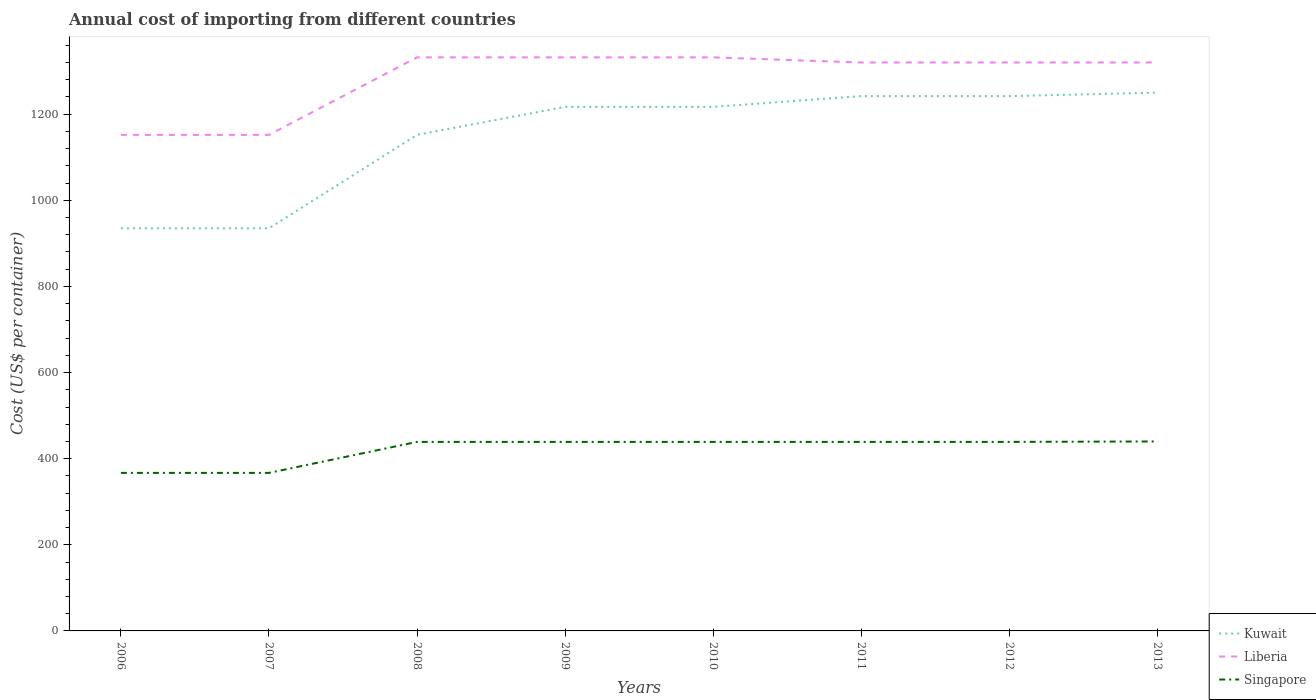Is the number of lines equal to the number of legend labels?
Provide a succinct answer. Yes. Across all years, what is the maximum total annual cost of importing in Liberia?
Ensure brevity in your answer.  1152. In which year was the total annual cost of importing in Singapore maximum?
Keep it short and to the point. 2006. What is the total total annual cost of importing in Kuwait in the graph?
Your answer should be very brief. -65. What is the difference between the highest and the second highest total annual cost of importing in Kuwait?
Give a very brief answer. 315. Is the total annual cost of importing in Singapore strictly greater than the total annual cost of importing in Kuwait over the years?
Give a very brief answer. Yes. Does the graph contain grids?
Provide a succinct answer. No. Where does the legend appear in the graph?
Provide a short and direct response. Bottom right. How many legend labels are there?
Offer a terse response. 3. What is the title of the graph?
Provide a succinct answer. Annual cost of importing from different countries. What is the label or title of the X-axis?
Your response must be concise. Years. What is the label or title of the Y-axis?
Your answer should be very brief. Cost (US$ per container). What is the Cost (US$ per container) of Kuwait in 2006?
Make the answer very short. 935. What is the Cost (US$ per container) of Liberia in 2006?
Ensure brevity in your answer.  1152. What is the Cost (US$ per container) of Singapore in 2006?
Give a very brief answer. 367. What is the Cost (US$ per container) of Kuwait in 2007?
Your answer should be compact. 935. What is the Cost (US$ per container) in Liberia in 2007?
Keep it short and to the point. 1152. What is the Cost (US$ per container) in Singapore in 2007?
Your answer should be compact. 367. What is the Cost (US$ per container) of Kuwait in 2008?
Make the answer very short. 1152. What is the Cost (US$ per container) in Liberia in 2008?
Offer a very short reply. 1332. What is the Cost (US$ per container) of Singapore in 2008?
Offer a terse response. 439. What is the Cost (US$ per container) in Kuwait in 2009?
Provide a short and direct response. 1217. What is the Cost (US$ per container) of Liberia in 2009?
Keep it short and to the point. 1332. What is the Cost (US$ per container) in Singapore in 2009?
Offer a terse response. 439. What is the Cost (US$ per container) in Kuwait in 2010?
Your answer should be compact. 1217. What is the Cost (US$ per container) of Liberia in 2010?
Keep it short and to the point. 1332. What is the Cost (US$ per container) in Singapore in 2010?
Your answer should be very brief. 439. What is the Cost (US$ per container) of Kuwait in 2011?
Your response must be concise. 1242. What is the Cost (US$ per container) in Liberia in 2011?
Ensure brevity in your answer.  1320. What is the Cost (US$ per container) of Singapore in 2011?
Provide a short and direct response. 439. What is the Cost (US$ per container) in Kuwait in 2012?
Give a very brief answer. 1242. What is the Cost (US$ per container) of Liberia in 2012?
Provide a succinct answer. 1320. What is the Cost (US$ per container) of Singapore in 2012?
Ensure brevity in your answer.  439. What is the Cost (US$ per container) in Kuwait in 2013?
Ensure brevity in your answer.  1250. What is the Cost (US$ per container) of Liberia in 2013?
Your response must be concise. 1320. What is the Cost (US$ per container) of Singapore in 2013?
Make the answer very short. 440. Across all years, what is the maximum Cost (US$ per container) of Kuwait?
Offer a very short reply. 1250. Across all years, what is the maximum Cost (US$ per container) in Liberia?
Your answer should be compact. 1332. Across all years, what is the maximum Cost (US$ per container) in Singapore?
Offer a terse response. 440. Across all years, what is the minimum Cost (US$ per container) in Kuwait?
Your answer should be compact. 935. Across all years, what is the minimum Cost (US$ per container) in Liberia?
Ensure brevity in your answer.  1152. Across all years, what is the minimum Cost (US$ per container) in Singapore?
Provide a short and direct response. 367. What is the total Cost (US$ per container) in Kuwait in the graph?
Your answer should be compact. 9190. What is the total Cost (US$ per container) of Liberia in the graph?
Offer a terse response. 1.03e+04. What is the total Cost (US$ per container) of Singapore in the graph?
Provide a succinct answer. 3369. What is the difference between the Cost (US$ per container) of Liberia in 2006 and that in 2007?
Offer a very short reply. 0. What is the difference between the Cost (US$ per container) in Singapore in 2006 and that in 2007?
Ensure brevity in your answer.  0. What is the difference between the Cost (US$ per container) in Kuwait in 2006 and that in 2008?
Your answer should be very brief. -217. What is the difference between the Cost (US$ per container) of Liberia in 2006 and that in 2008?
Provide a short and direct response. -180. What is the difference between the Cost (US$ per container) of Singapore in 2006 and that in 2008?
Offer a terse response. -72. What is the difference between the Cost (US$ per container) of Kuwait in 2006 and that in 2009?
Give a very brief answer. -282. What is the difference between the Cost (US$ per container) in Liberia in 2006 and that in 2009?
Your answer should be compact. -180. What is the difference between the Cost (US$ per container) in Singapore in 2006 and that in 2009?
Give a very brief answer. -72. What is the difference between the Cost (US$ per container) of Kuwait in 2006 and that in 2010?
Your response must be concise. -282. What is the difference between the Cost (US$ per container) of Liberia in 2006 and that in 2010?
Keep it short and to the point. -180. What is the difference between the Cost (US$ per container) of Singapore in 2006 and that in 2010?
Your response must be concise. -72. What is the difference between the Cost (US$ per container) in Kuwait in 2006 and that in 2011?
Provide a short and direct response. -307. What is the difference between the Cost (US$ per container) of Liberia in 2006 and that in 2011?
Offer a terse response. -168. What is the difference between the Cost (US$ per container) in Singapore in 2006 and that in 2011?
Offer a terse response. -72. What is the difference between the Cost (US$ per container) in Kuwait in 2006 and that in 2012?
Your response must be concise. -307. What is the difference between the Cost (US$ per container) of Liberia in 2006 and that in 2012?
Make the answer very short. -168. What is the difference between the Cost (US$ per container) of Singapore in 2006 and that in 2012?
Keep it short and to the point. -72. What is the difference between the Cost (US$ per container) of Kuwait in 2006 and that in 2013?
Offer a very short reply. -315. What is the difference between the Cost (US$ per container) of Liberia in 2006 and that in 2013?
Your response must be concise. -168. What is the difference between the Cost (US$ per container) of Singapore in 2006 and that in 2013?
Ensure brevity in your answer.  -73. What is the difference between the Cost (US$ per container) in Kuwait in 2007 and that in 2008?
Make the answer very short. -217. What is the difference between the Cost (US$ per container) of Liberia in 2007 and that in 2008?
Give a very brief answer. -180. What is the difference between the Cost (US$ per container) in Singapore in 2007 and that in 2008?
Offer a very short reply. -72. What is the difference between the Cost (US$ per container) of Kuwait in 2007 and that in 2009?
Keep it short and to the point. -282. What is the difference between the Cost (US$ per container) in Liberia in 2007 and that in 2009?
Your answer should be compact. -180. What is the difference between the Cost (US$ per container) of Singapore in 2007 and that in 2009?
Give a very brief answer. -72. What is the difference between the Cost (US$ per container) of Kuwait in 2007 and that in 2010?
Give a very brief answer. -282. What is the difference between the Cost (US$ per container) in Liberia in 2007 and that in 2010?
Your answer should be compact. -180. What is the difference between the Cost (US$ per container) of Singapore in 2007 and that in 2010?
Make the answer very short. -72. What is the difference between the Cost (US$ per container) of Kuwait in 2007 and that in 2011?
Your answer should be very brief. -307. What is the difference between the Cost (US$ per container) in Liberia in 2007 and that in 2011?
Your answer should be compact. -168. What is the difference between the Cost (US$ per container) of Singapore in 2007 and that in 2011?
Ensure brevity in your answer.  -72. What is the difference between the Cost (US$ per container) in Kuwait in 2007 and that in 2012?
Keep it short and to the point. -307. What is the difference between the Cost (US$ per container) in Liberia in 2007 and that in 2012?
Offer a very short reply. -168. What is the difference between the Cost (US$ per container) of Singapore in 2007 and that in 2012?
Your response must be concise. -72. What is the difference between the Cost (US$ per container) in Kuwait in 2007 and that in 2013?
Your response must be concise. -315. What is the difference between the Cost (US$ per container) of Liberia in 2007 and that in 2013?
Offer a very short reply. -168. What is the difference between the Cost (US$ per container) of Singapore in 2007 and that in 2013?
Offer a terse response. -73. What is the difference between the Cost (US$ per container) of Kuwait in 2008 and that in 2009?
Offer a very short reply. -65. What is the difference between the Cost (US$ per container) of Singapore in 2008 and that in 2009?
Offer a terse response. 0. What is the difference between the Cost (US$ per container) of Kuwait in 2008 and that in 2010?
Your response must be concise. -65. What is the difference between the Cost (US$ per container) in Kuwait in 2008 and that in 2011?
Keep it short and to the point. -90. What is the difference between the Cost (US$ per container) in Liberia in 2008 and that in 2011?
Provide a short and direct response. 12. What is the difference between the Cost (US$ per container) in Kuwait in 2008 and that in 2012?
Offer a very short reply. -90. What is the difference between the Cost (US$ per container) in Liberia in 2008 and that in 2012?
Provide a short and direct response. 12. What is the difference between the Cost (US$ per container) of Kuwait in 2008 and that in 2013?
Provide a short and direct response. -98. What is the difference between the Cost (US$ per container) of Singapore in 2008 and that in 2013?
Your response must be concise. -1. What is the difference between the Cost (US$ per container) in Liberia in 2009 and that in 2010?
Offer a terse response. 0. What is the difference between the Cost (US$ per container) in Liberia in 2009 and that in 2011?
Give a very brief answer. 12. What is the difference between the Cost (US$ per container) in Singapore in 2009 and that in 2011?
Your answer should be very brief. 0. What is the difference between the Cost (US$ per container) in Kuwait in 2009 and that in 2013?
Keep it short and to the point. -33. What is the difference between the Cost (US$ per container) in Liberia in 2010 and that in 2011?
Your answer should be compact. 12. What is the difference between the Cost (US$ per container) in Singapore in 2010 and that in 2011?
Make the answer very short. 0. What is the difference between the Cost (US$ per container) in Singapore in 2010 and that in 2012?
Offer a very short reply. 0. What is the difference between the Cost (US$ per container) in Kuwait in 2010 and that in 2013?
Provide a succinct answer. -33. What is the difference between the Cost (US$ per container) in Liberia in 2010 and that in 2013?
Your answer should be very brief. 12. What is the difference between the Cost (US$ per container) of Singapore in 2010 and that in 2013?
Provide a succinct answer. -1. What is the difference between the Cost (US$ per container) in Liberia in 2011 and that in 2012?
Your answer should be very brief. 0. What is the difference between the Cost (US$ per container) of Kuwait in 2011 and that in 2013?
Provide a short and direct response. -8. What is the difference between the Cost (US$ per container) in Liberia in 2011 and that in 2013?
Ensure brevity in your answer.  0. What is the difference between the Cost (US$ per container) of Liberia in 2012 and that in 2013?
Offer a terse response. 0. What is the difference between the Cost (US$ per container) in Singapore in 2012 and that in 2013?
Your response must be concise. -1. What is the difference between the Cost (US$ per container) in Kuwait in 2006 and the Cost (US$ per container) in Liberia in 2007?
Give a very brief answer. -217. What is the difference between the Cost (US$ per container) of Kuwait in 2006 and the Cost (US$ per container) of Singapore in 2007?
Your answer should be compact. 568. What is the difference between the Cost (US$ per container) in Liberia in 2006 and the Cost (US$ per container) in Singapore in 2007?
Your answer should be very brief. 785. What is the difference between the Cost (US$ per container) of Kuwait in 2006 and the Cost (US$ per container) of Liberia in 2008?
Make the answer very short. -397. What is the difference between the Cost (US$ per container) in Kuwait in 2006 and the Cost (US$ per container) in Singapore in 2008?
Offer a very short reply. 496. What is the difference between the Cost (US$ per container) in Liberia in 2006 and the Cost (US$ per container) in Singapore in 2008?
Your response must be concise. 713. What is the difference between the Cost (US$ per container) of Kuwait in 2006 and the Cost (US$ per container) of Liberia in 2009?
Provide a succinct answer. -397. What is the difference between the Cost (US$ per container) in Kuwait in 2006 and the Cost (US$ per container) in Singapore in 2009?
Your answer should be compact. 496. What is the difference between the Cost (US$ per container) of Liberia in 2006 and the Cost (US$ per container) of Singapore in 2009?
Your response must be concise. 713. What is the difference between the Cost (US$ per container) in Kuwait in 2006 and the Cost (US$ per container) in Liberia in 2010?
Offer a terse response. -397. What is the difference between the Cost (US$ per container) in Kuwait in 2006 and the Cost (US$ per container) in Singapore in 2010?
Keep it short and to the point. 496. What is the difference between the Cost (US$ per container) of Liberia in 2006 and the Cost (US$ per container) of Singapore in 2010?
Offer a terse response. 713. What is the difference between the Cost (US$ per container) of Kuwait in 2006 and the Cost (US$ per container) of Liberia in 2011?
Your answer should be very brief. -385. What is the difference between the Cost (US$ per container) of Kuwait in 2006 and the Cost (US$ per container) of Singapore in 2011?
Keep it short and to the point. 496. What is the difference between the Cost (US$ per container) of Liberia in 2006 and the Cost (US$ per container) of Singapore in 2011?
Your answer should be compact. 713. What is the difference between the Cost (US$ per container) of Kuwait in 2006 and the Cost (US$ per container) of Liberia in 2012?
Offer a very short reply. -385. What is the difference between the Cost (US$ per container) in Kuwait in 2006 and the Cost (US$ per container) in Singapore in 2012?
Give a very brief answer. 496. What is the difference between the Cost (US$ per container) of Liberia in 2006 and the Cost (US$ per container) of Singapore in 2012?
Make the answer very short. 713. What is the difference between the Cost (US$ per container) of Kuwait in 2006 and the Cost (US$ per container) of Liberia in 2013?
Your answer should be very brief. -385. What is the difference between the Cost (US$ per container) in Kuwait in 2006 and the Cost (US$ per container) in Singapore in 2013?
Offer a terse response. 495. What is the difference between the Cost (US$ per container) in Liberia in 2006 and the Cost (US$ per container) in Singapore in 2013?
Keep it short and to the point. 712. What is the difference between the Cost (US$ per container) in Kuwait in 2007 and the Cost (US$ per container) in Liberia in 2008?
Ensure brevity in your answer.  -397. What is the difference between the Cost (US$ per container) of Kuwait in 2007 and the Cost (US$ per container) of Singapore in 2008?
Your answer should be very brief. 496. What is the difference between the Cost (US$ per container) of Liberia in 2007 and the Cost (US$ per container) of Singapore in 2008?
Give a very brief answer. 713. What is the difference between the Cost (US$ per container) of Kuwait in 2007 and the Cost (US$ per container) of Liberia in 2009?
Provide a short and direct response. -397. What is the difference between the Cost (US$ per container) of Kuwait in 2007 and the Cost (US$ per container) of Singapore in 2009?
Provide a succinct answer. 496. What is the difference between the Cost (US$ per container) in Liberia in 2007 and the Cost (US$ per container) in Singapore in 2009?
Provide a short and direct response. 713. What is the difference between the Cost (US$ per container) in Kuwait in 2007 and the Cost (US$ per container) in Liberia in 2010?
Your response must be concise. -397. What is the difference between the Cost (US$ per container) in Kuwait in 2007 and the Cost (US$ per container) in Singapore in 2010?
Your response must be concise. 496. What is the difference between the Cost (US$ per container) in Liberia in 2007 and the Cost (US$ per container) in Singapore in 2010?
Your answer should be very brief. 713. What is the difference between the Cost (US$ per container) of Kuwait in 2007 and the Cost (US$ per container) of Liberia in 2011?
Give a very brief answer. -385. What is the difference between the Cost (US$ per container) of Kuwait in 2007 and the Cost (US$ per container) of Singapore in 2011?
Your response must be concise. 496. What is the difference between the Cost (US$ per container) in Liberia in 2007 and the Cost (US$ per container) in Singapore in 2011?
Your response must be concise. 713. What is the difference between the Cost (US$ per container) in Kuwait in 2007 and the Cost (US$ per container) in Liberia in 2012?
Offer a terse response. -385. What is the difference between the Cost (US$ per container) of Kuwait in 2007 and the Cost (US$ per container) of Singapore in 2012?
Ensure brevity in your answer.  496. What is the difference between the Cost (US$ per container) of Liberia in 2007 and the Cost (US$ per container) of Singapore in 2012?
Offer a terse response. 713. What is the difference between the Cost (US$ per container) in Kuwait in 2007 and the Cost (US$ per container) in Liberia in 2013?
Keep it short and to the point. -385. What is the difference between the Cost (US$ per container) in Kuwait in 2007 and the Cost (US$ per container) in Singapore in 2013?
Provide a succinct answer. 495. What is the difference between the Cost (US$ per container) of Liberia in 2007 and the Cost (US$ per container) of Singapore in 2013?
Offer a terse response. 712. What is the difference between the Cost (US$ per container) of Kuwait in 2008 and the Cost (US$ per container) of Liberia in 2009?
Offer a terse response. -180. What is the difference between the Cost (US$ per container) of Kuwait in 2008 and the Cost (US$ per container) of Singapore in 2009?
Provide a succinct answer. 713. What is the difference between the Cost (US$ per container) of Liberia in 2008 and the Cost (US$ per container) of Singapore in 2009?
Provide a short and direct response. 893. What is the difference between the Cost (US$ per container) in Kuwait in 2008 and the Cost (US$ per container) in Liberia in 2010?
Provide a short and direct response. -180. What is the difference between the Cost (US$ per container) of Kuwait in 2008 and the Cost (US$ per container) of Singapore in 2010?
Make the answer very short. 713. What is the difference between the Cost (US$ per container) of Liberia in 2008 and the Cost (US$ per container) of Singapore in 2010?
Your response must be concise. 893. What is the difference between the Cost (US$ per container) in Kuwait in 2008 and the Cost (US$ per container) in Liberia in 2011?
Offer a terse response. -168. What is the difference between the Cost (US$ per container) in Kuwait in 2008 and the Cost (US$ per container) in Singapore in 2011?
Your answer should be compact. 713. What is the difference between the Cost (US$ per container) of Liberia in 2008 and the Cost (US$ per container) of Singapore in 2011?
Provide a short and direct response. 893. What is the difference between the Cost (US$ per container) in Kuwait in 2008 and the Cost (US$ per container) in Liberia in 2012?
Offer a very short reply. -168. What is the difference between the Cost (US$ per container) in Kuwait in 2008 and the Cost (US$ per container) in Singapore in 2012?
Offer a terse response. 713. What is the difference between the Cost (US$ per container) in Liberia in 2008 and the Cost (US$ per container) in Singapore in 2012?
Your response must be concise. 893. What is the difference between the Cost (US$ per container) of Kuwait in 2008 and the Cost (US$ per container) of Liberia in 2013?
Ensure brevity in your answer.  -168. What is the difference between the Cost (US$ per container) in Kuwait in 2008 and the Cost (US$ per container) in Singapore in 2013?
Offer a very short reply. 712. What is the difference between the Cost (US$ per container) of Liberia in 2008 and the Cost (US$ per container) of Singapore in 2013?
Offer a terse response. 892. What is the difference between the Cost (US$ per container) of Kuwait in 2009 and the Cost (US$ per container) of Liberia in 2010?
Offer a terse response. -115. What is the difference between the Cost (US$ per container) of Kuwait in 2009 and the Cost (US$ per container) of Singapore in 2010?
Offer a terse response. 778. What is the difference between the Cost (US$ per container) in Liberia in 2009 and the Cost (US$ per container) in Singapore in 2010?
Provide a succinct answer. 893. What is the difference between the Cost (US$ per container) of Kuwait in 2009 and the Cost (US$ per container) of Liberia in 2011?
Provide a short and direct response. -103. What is the difference between the Cost (US$ per container) of Kuwait in 2009 and the Cost (US$ per container) of Singapore in 2011?
Your answer should be very brief. 778. What is the difference between the Cost (US$ per container) in Liberia in 2009 and the Cost (US$ per container) in Singapore in 2011?
Your response must be concise. 893. What is the difference between the Cost (US$ per container) in Kuwait in 2009 and the Cost (US$ per container) in Liberia in 2012?
Provide a succinct answer. -103. What is the difference between the Cost (US$ per container) in Kuwait in 2009 and the Cost (US$ per container) in Singapore in 2012?
Provide a short and direct response. 778. What is the difference between the Cost (US$ per container) in Liberia in 2009 and the Cost (US$ per container) in Singapore in 2012?
Offer a terse response. 893. What is the difference between the Cost (US$ per container) of Kuwait in 2009 and the Cost (US$ per container) of Liberia in 2013?
Your answer should be very brief. -103. What is the difference between the Cost (US$ per container) of Kuwait in 2009 and the Cost (US$ per container) of Singapore in 2013?
Provide a short and direct response. 777. What is the difference between the Cost (US$ per container) of Liberia in 2009 and the Cost (US$ per container) of Singapore in 2013?
Ensure brevity in your answer.  892. What is the difference between the Cost (US$ per container) of Kuwait in 2010 and the Cost (US$ per container) of Liberia in 2011?
Ensure brevity in your answer.  -103. What is the difference between the Cost (US$ per container) of Kuwait in 2010 and the Cost (US$ per container) of Singapore in 2011?
Keep it short and to the point. 778. What is the difference between the Cost (US$ per container) in Liberia in 2010 and the Cost (US$ per container) in Singapore in 2011?
Your answer should be very brief. 893. What is the difference between the Cost (US$ per container) in Kuwait in 2010 and the Cost (US$ per container) in Liberia in 2012?
Provide a short and direct response. -103. What is the difference between the Cost (US$ per container) of Kuwait in 2010 and the Cost (US$ per container) of Singapore in 2012?
Offer a terse response. 778. What is the difference between the Cost (US$ per container) in Liberia in 2010 and the Cost (US$ per container) in Singapore in 2012?
Provide a succinct answer. 893. What is the difference between the Cost (US$ per container) of Kuwait in 2010 and the Cost (US$ per container) of Liberia in 2013?
Keep it short and to the point. -103. What is the difference between the Cost (US$ per container) in Kuwait in 2010 and the Cost (US$ per container) in Singapore in 2013?
Offer a very short reply. 777. What is the difference between the Cost (US$ per container) of Liberia in 2010 and the Cost (US$ per container) of Singapore in 2013?
Keep it short and to the point. 892. What is the difference between the Cost (US$ per container) of Kuwait in 2011 and the Cost (US$ per container) of Liberia in 2012?
Your response must be concise. -78. What is the difference between the Cost (US$ per container) of Kuwait in 2011 and the Cost (US$ per container) of Singapore in 2012?
Your answer should be very brief. 803. What is the difference between the Cost (US$ per container) in Liberia in 2011 and the Cost (US$ per container) in Singapore in 2012?
Offer a very short reply. 881. What is the difference between the Cost (US$ per container) of Kuwait in 2011 and the Cost (US$ per container) of Liberia in 2013?
Make the answer very short. -78. What is the difference between the Cost (US$ per container) of Kuwait in 2011 and the Cost (US$ per container) of Singapore in 2013?
Make the answer very short. 802. What is the difference between the Cost (US$ per container) of Liberia in 2011 and the Cost (US$ per container) of Singapore in 2013?
Keep it short and to the point. 880. What is the difference between the Cost (US$ per container) of Kuwait in 2012 and the Cost (US$ per container) of Liberia in 2013?
Ensure brevity in your answer.  -78. What is the difference between the Cost (US$ per container) of Kuwait in 2012 and the Cost (US$ per container) of Singapore in 2013?
Provide a succinct answer. 802. What is the difference between the Cost (US$ per container) of Liberia in 2012 and the Cost (US$ per container) of Singapore in 2013?
Keep it short and to the point. 880. What is the average Cost (US$ per container) of Kuwait per year?
Keep it short and to the point. 1148.75. What is the average Cost (US$ per container) in Liberia per year?
Offer a very short reply. 1282.5. What is the average Cost (US$ per container) of Singapore per year?
Provide a short and direct response. 421.12. In the year 2006, what is the difference between the Cost (US$ per container) of Kuwait and Cost (US$ per container) of Liberia?
Offer a terse response. -217. In the year 2006, what is the difference between the Cost (US$ per container) of Kuwait and Cost (US$ per container) of Singapore?
Offer a terse response. 568. In the year 2006, what is the difference between the Cost (US$ per container) in Liberia and Cost (US$ per container) in Singapore?
Provide a short and direct response. 785. In the year 2007, what is the difference between the Cost (US$ per container) of Kuwait and Cost (US$ per container) of Liberia?
Offer a terse response. -217. In the year 2007, what is the difference between the Cost (US$ per container) of Kuwait and Cost (US$ per container) of Singapore?
Provide a short and direct response. 568. In the year 2007, what is the difference between the Cost (US$ per container) of Liberia and Cost (US$ per container) of Singapore?
Offer a terse response. 785. In the year 2008, what is the difference between the Cost (US$ per container) of Kuwait and Cost (US$ per container) of Liberia?
Keep it short and to the point. -180. In the year 2008, what is the difference between the Cost (US$ per container) of Kuwait and Cost (US$ per container) of Singapore?
Ensure brevity in your answer.  713. In the year 2008, what is the difference between the Cost (US$ per container) of Liberia and Cost (US$ per container) of Singapore?
Make the answer very short. 893. In the year 2009, what is the difference between the Cost (US$ per container) in Kuwait and Cost (US$ per container) in Liberia?
Offer a very short reply. -115. In the year 2009, what is the difference between the Cost (US$ per container) of Kuwait and Cost (US$ per container) of Singapore?
Offer a terse response. 778. In the year 2009, what is the difference between the Cost (US$ per container) of Liberia and Cost (US$ per container) of Singapore?
Offer a terse response. 893. In the year 2010, what is the difference between the Cost (US$ per container) in Kuwait and Cost (US$ per container) in Liberia?
Offer a very short reply. -115. In the year 2010, what is the difference between the Cost (US$ per container) of Kuwait and Cost (US$ per container) of Singapore?
Provide a short and direct response. 778. In the year 2010, what is the difference between the Cost (US$ per container) in Liberia and Cost (US$ per container) in Singapore?
Ensure brevity in your answer.  893. In the year 2011, what is the difference between the Cost (US$ per container) in Kuwait and Cost (US$ per container) in Liberia?
Your answer should be very brief. -78. In the year 2011, what is the difference between the Cost (US$ per container) of Kuwait and Cost (US$ per container) of Singapore?
Provide a short and direct response. 803. In the year 2011, what is the difference between the Cost (US$ per container) of Liberia and Cost (US$ per container) of Singapore?
Make the answer very short. 881. In the year 2012, what is the difference between the Cost (US$ per container) of Kuwait and Cost (US$ per container) of Liberia?
Your response must be concise. -78. In the year 2012, what is the difference between the Cost (US$ per container) in Kuwait and Cost (US$ per container) in Singapore?
Offer a very short reply. 803. In the year 2012, what is the difference between the Cost (US$ per container) of Liberia and Cost (US$ per container) of Singapore?
Your response must be concise. 881. In the year 2013, what is the difference between the Cost (US$ per container) in Kuwait and Cost (US$ per container) in Liberia?
Offer a very short reply. -70. In the year 2013, what is the difference between the Cost (US$ per container) of Kuwait and Cost (US$ per container) of Singapore?
Your answer should be compact. 810. In the year 2013, what is the difference between the Cost (US$ per container) in Liberia and Cost (US$ per container) in Singapore?
Make the answer very short. 880. What is the ratio of the Cost (US$ per container) of Kuwait in 2006 to that in 2007?
Give a very brief answer. 1. What is the ratio of the Cost (US$ per container) of Kuwait in 2006 to that in 2008?
Make the answer very short. 0.81. What is the ratio of the Cost (US$ per container) in Liberia in 2006 to that in 2008?
Your response must be concise. 0.86. What is the ratio of the Cost (US$ per container) in Singapore in 2006 to that in 2008?
Give a very brief answer. 0.84. What is the ratio of the Cost (US$ per container) in Kuwait in 2006 to that in 2009?
Provide a succinct answer. 0.77. What is the ratio of the Cost (US$ per container) of Liberia in 2006 to that in 2009?
Your answer should be very brief. 0.86. What is the ratio of the Cost (US$ per container) in Singapore in 2006 to that in 2009?
Give a very brief answer. 0.84. What is the ratio of the Cost (US$ per container) of Kuwait in 2006 to that in 2010?
Make the answer very short. 0.77. What is the ratio of the Cost (US$ per container) of Liberia in 2006 to that in 2010?
Provide a succinct answer. 0.86. What is the ratio of the Cost (US$ per container) in Singapore in 2006 to that in 2010?
Give a very brief answer. 0.84. What is the ratio of the Cost (US$ per container) of Kuwait in 2006 to that in 2011?
Keep it short and to the point. 0.75. What is the ratio of the Cost (US$ per container) in Liberia in 2006 to that in 2011?
Offer a very short reply. 0.87. What is the ratio of the Cost (US$ per container) of Singapore in 2006 to that in 2011?
Give a very brief answer. 0.84. What is the ratio of the Cost (US$ per container) of Kuwait in 2006 to that in 2012?
Give a very brief answer. 0.75. What is the ratio of the Cost (US$ per container) of Liberia in 2006 to that in 2012?
Your answer should be very brief. 0.87. What is the ratio of the Cost (US$ per container) of Singapore in 2006 to that in 2012?
Provide a succinct answer. 0.84. What is the ratio of the Cost (US$ per container) of Kuwait in 2006 to that in 2013?
Your answer should be very brief. 0.75. What is the ratio of the Cost (US$ per container) of Liberia in 2006 to that in 2013?
Offer a very short reply. 0.87. What is the ratio of the Cost (US$ per container) of Singapore in 2006 to that in 2013?
Keep it short and to the point. 0.83. What is the ratio of the Cost (US$ per container) of Kuwait in 2007 to that in 2008?
Offer a very short reply. 0.81. What is the ratio of the Cost (US$ per container) of Liberia in 2007 to that in 2008?
Your answer should be very brief. 0.86. What is the ratio of the Cost (US$ per container) in Singapore in 2007 to that in 2008?
Ensure brevity in your answer.  0.84. What is the ratio of the Cost (US$ per container) in Kuwait in 2007 to that in 2009?
Your answer should be compact. 0.77. What is the ratio of the Cost (US$ per container) in Liberia in 2007 to that in 2009?
Provide a short and direct response. 0.86. What is the ratio of the Cost (US$ per container) of Singapore in 2007 to that in 2009?
Offer a terse response. 0.84. What is the ratio of the Cost (US$ per container) in Kuwait in 2007 to that in 2010?
Provide a succinct answer. 0.77. What is the ratio of the Cost (US$ per container) of Liberia in 2007 to that in 2010?
Your answer should be very brief. 0.86. What is the ratio of the Cost (US$ per container) in Singapore in 2007 to that in 2010?
Your answer should be compact. 0.84. What is the ratio of the Cost (US$ per container) of Kuwait in 2007 to that in 2011?
Your answer should be very brief. 0.75. What is the ratio of the Cost (US$ per container) of Liberia in 2007 to that in 2011?
Make the answer very short. 0.87. What is the ratio of the Cost (US$ per container) of Singapore in 2007 to that in 2011?
Make the answer very short. 0.84. What is the ratio of the Cost (US$ per container) in Kuwait in 2007 to that in 2012?
Keep it short and to the point. 0.75. What is the ratio of the Cost (US$ per container) in Liberia in 2007 to that in 2012?
Provide a short and direct response. 0.87. What is the ratio of the Cost (US$ per container) of Singapore in 2007 to that in 2012?
Make the answer very short. 0.84. What is the ratio of the Cost (US$ per container) of Kuwait in 2007 to that in 2013?
Provide a short and direct response. 0.75. What is the ratio of the Cost (US$ per container) in Liberia in 2007 to that in 2013?
Make the answer very short. 0.87. What is the ratio of the Cost (US$ per container) in Singapore in 2007 to that in 2013?
Keep it short and to the point. 0.83. What is the ratio of the Cost (US$ per container) of Kuwait in 2008 to that in 2009?
Ensure brevity in your answer.  0.95. What is the ratio of the Cost (US$ per container) of Kuwait in 2008 to that in 2010?
Provide a short and direct response. 0.95. What is the ratio of the Cost (US$ per container) in Liberia in 2008 to that in 2010?
Provide a short and direct response. 1. What is the ratio of the Cost (US$ per container) in Singapore in 2008 to that in 2010?
Provide a short and direct response. 1. What is the ratio of the Cost (US$ per container) in Kuwait in 2008 to that in 2011?
Ensure brevity in your answer.  0.93. What is the ratio of the Cost (US$ per container) in Liberia in 2008 to that in 2011?
Provide a succinct answer. 1.01. What is the ratio of the Cost (US$ per container) of Kuwait in 2008 to that in 2012?
Provide a short and direct response. 0.93. What is the ratio of the Cost (US$ per container) of Liberia in 2008 to that in 2012?
Give a very brief answer. 1.01. What is the ratio of the Cost (US$ per container) in Kuwait in 2008 to that in 2013?
Your answer should be compact. 0.92. What is the ratio of the Cost (US$ per container) in Liberia in 2008 to that in 2013?
Your response must be concise. 1.01. What is the ratio of the Cost (US$ per container) in Singapore in 2008 to that in 2013?
Provide a short and direct response. 1. What is the ratio of the Cost (US$ per container) in Singapore in 2009 to that in 2010?
Ensure brevity in your answer.  1. What is the ratio of the Cost (US$ per container) of Kuwait in 2009 to that in 2011?
Ensure brevity in your answer.  0.98. What is the ratio of the Cost (US$ per container) of Liberia in 2009 to that in 2011?
Offer a terse response. 1.01. What is the ratio of the Cost (US$ per container) in Singapore in 2009 to that in 2011?
Make the answer very short. 1. What is the ratio of the Cost (US$ per container) of Kuwait in 2009 to that in 2012?
Provide a short and direct response. 0.98. What is the ratio of the Cost (US$ per container) in Liberia in 2009 to that in 2012?
Provide a succinct answer. 1.01. What is the ratio of the Cost (US$ per container) in Kuwait in 2009 to that in 2013?
Give a very brief answer. 0.97. What is the ratio of the Cost (US$ per container) in Liberia in 2009 to that in 2013?
Ensure brevity in your answer.  1.01. What is the ratio of the Cost (US$ per container) in Singapore in 2009 to that in 2013?
Ensure brevity in your answer.  1. What is the ratio of the Cost (US$ per container) in Kuwait in 2010 to that in 2011?
Ensure brevity in your answer.  0.98. What is the ratio of the Cost (US$ per container) in Liberia in 2010 to that in 2011?
Offer a very short reply. 1.01. What is the ratio of the Cost (US$ per container) of Kuwait in 2010 to that in 2012?
Give a very brief answer. 0.98. What is the ratio of the Cost (US$ per container) of Liberia in 2010 to that in 2012?
Provide a short and direct response. 1.01. What is the ratio of the Cost (US$ per container) of Singapore in 2010 to that in 2012?
Ensure brevity in your answer.  1. What is the ratio of the Cost (US$ per container) in Kuwait in 2010 to that in 2013?
Offer a very short reply. 0.97. What is the ratio of the Cost (US$ per container) of Liberia in 2010 to that in 2013?
Provide a short and direct response. 1.01. What is the ratio of the Cost (US$ per container) in Singapore in 2010 to that in 2013?
Ensure brevity in your answer.  1. What is the ratio of the Cost (US$ per container) in Liberia in 2011 to that in 2012?
Your response must be concise. 1. What is the ratio of the Cost (US$ per container) of Singapore in 2011 to that in 2012?
Offer a very short reply. 1. What is the ratio of the Cost (US$ per container) in Kuwait in 2011 to that in 2013?
Your response must be concise. 0.99. What is the ratio of the Cost (US$ per container) of Liberia in 2011 to that in 2013?
Your response must be concise. 1. What is the ratio of the Cost (US$ per container) of Singapore in 2011 to that in 2013?
Make the answer very short. 1. What is the ratio of the Cost (US$ per container) in Kuwait in 2012 to that in 2013?
Give a very brief answer. 0.99. What is the ratio of the Cost (US$ per container) in Liberia in 2012 to that in 2013?
Provide a short and direct response. 1. What is the ratio of the Cost (US$ per container) of Singapore in 2012 to that in 2013?
Offer a very short reply. 1. What is the difference between the highest and the second highest Cost (US$ per container) in Kuwait?
Your answer should be compact. 8. What is the difference between the highest and the second highest Cost (US$ per container) of Liberia?
Your answer should be compact. 0. What is the difference between the highest and the lowest Cost (US$ per container) of Kuwait?
Your answer should be very brief. 315. What is the difference between the highest and the lowest Cost (US$ per container) of Liberia?
Keep it short and to the point. 180. 